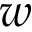<formula> <loc_0><loc_0><loc_500><loc_500>w</formula> 